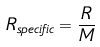<formula> <loc_0><loc_0><loc_500><loc_500>R _ { s p e c i f i c } = \frac { R } { M }</formula> 